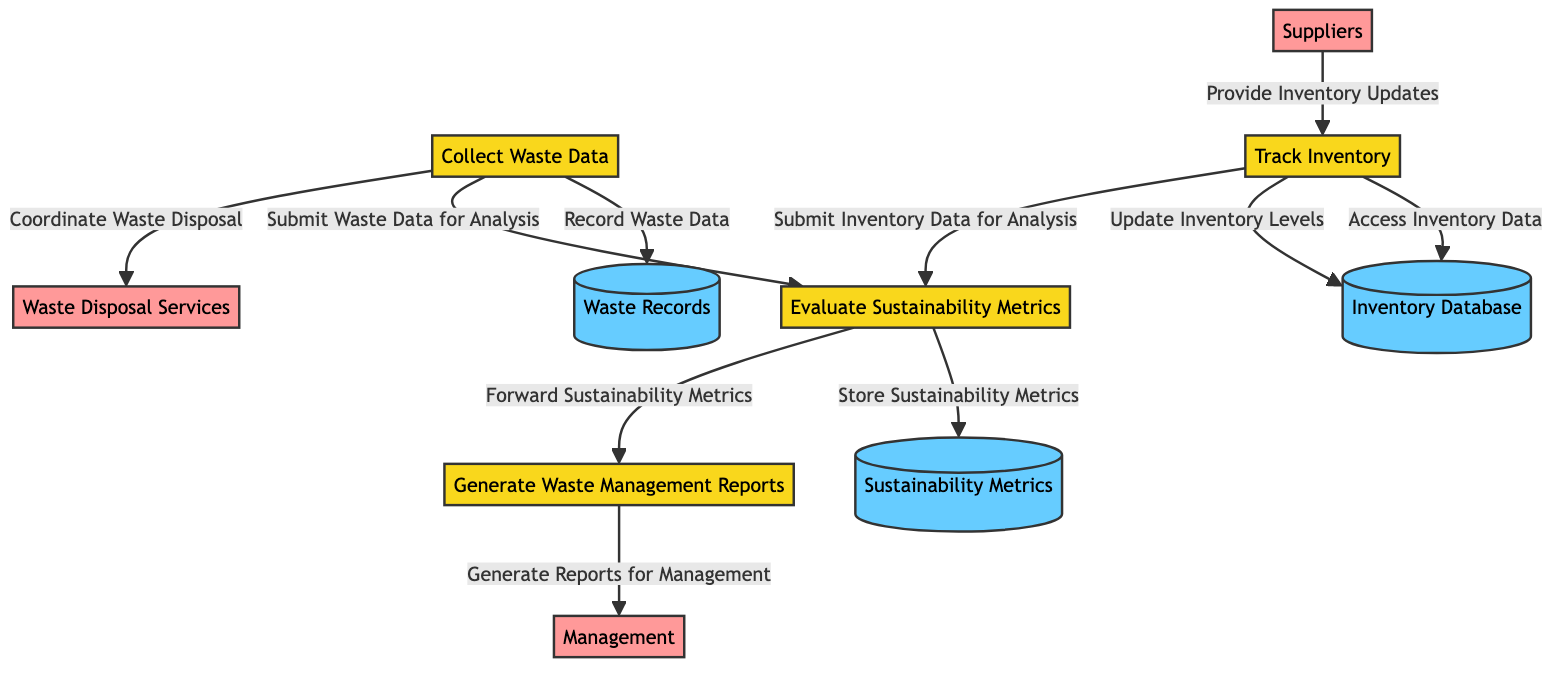What is the first process represented in the diagram? The first process is identified as "Collect Waste Data," which is labeled as P1 in the diagram.
Answer: Collect Waste Data How many data stores are shown in the diagram? There are three data stores labeled as Waste Records, Inventory Database, and Sustainability Metrics, indicating that the total count is 3.
Answer: 3 What relationship exists between "Track Inventory" and "Waste Records"? The "Track Inventory" process does not have a direct relationship with "Waste Records." Instead, it connects to the Inventory Database and submits data for analysis to the Evaluate Sustainability Metrics process but does not interact directly with Waste Records.
Answer: No direct relationship Which external entity provides updates to the "Track Inventory" process? The external entity that provides updates is labeled as "Suppliers," which are noted in the diagram as external vendors that provide fish and deli products.
Answer: Suppliers What does the "Evaluate Sustainability Metrics" process submit for analysis? The "Evaluate Sustainability Metrics" process submits data from both the "Collect Waste Data" and "Track Inventory" processes to analyze sustainability metrics.
Answer: Waste Data and Inventory Data Which process generates reports for Management? The "Generate Waste Management Reports" process specifically carries out the task of generating reports for management, represented by the P4 process communicated through the F9 data flow.
Answer: Generate Waste Management Reports What type of data is stored in the "Sustainability Metrics" data store? The "Sustainability Metrics" data store holds metrics related to sustainability efforts, as indicated in the description of D3 in the diagram.
Answer: Sustainability metrics How many external entities are involved in the diagram? The diagram illustrates three external entities, which are Suppliers, Waste Disposal Services, and Management. Thus, the total count is 3.
Answer: 3 What is the final action taken in the process flow? The final action is the generation of reports for management, which is the last process before the diagram indicates it flows out to the external entity, Management.
Answer: Generate Reports for Management 